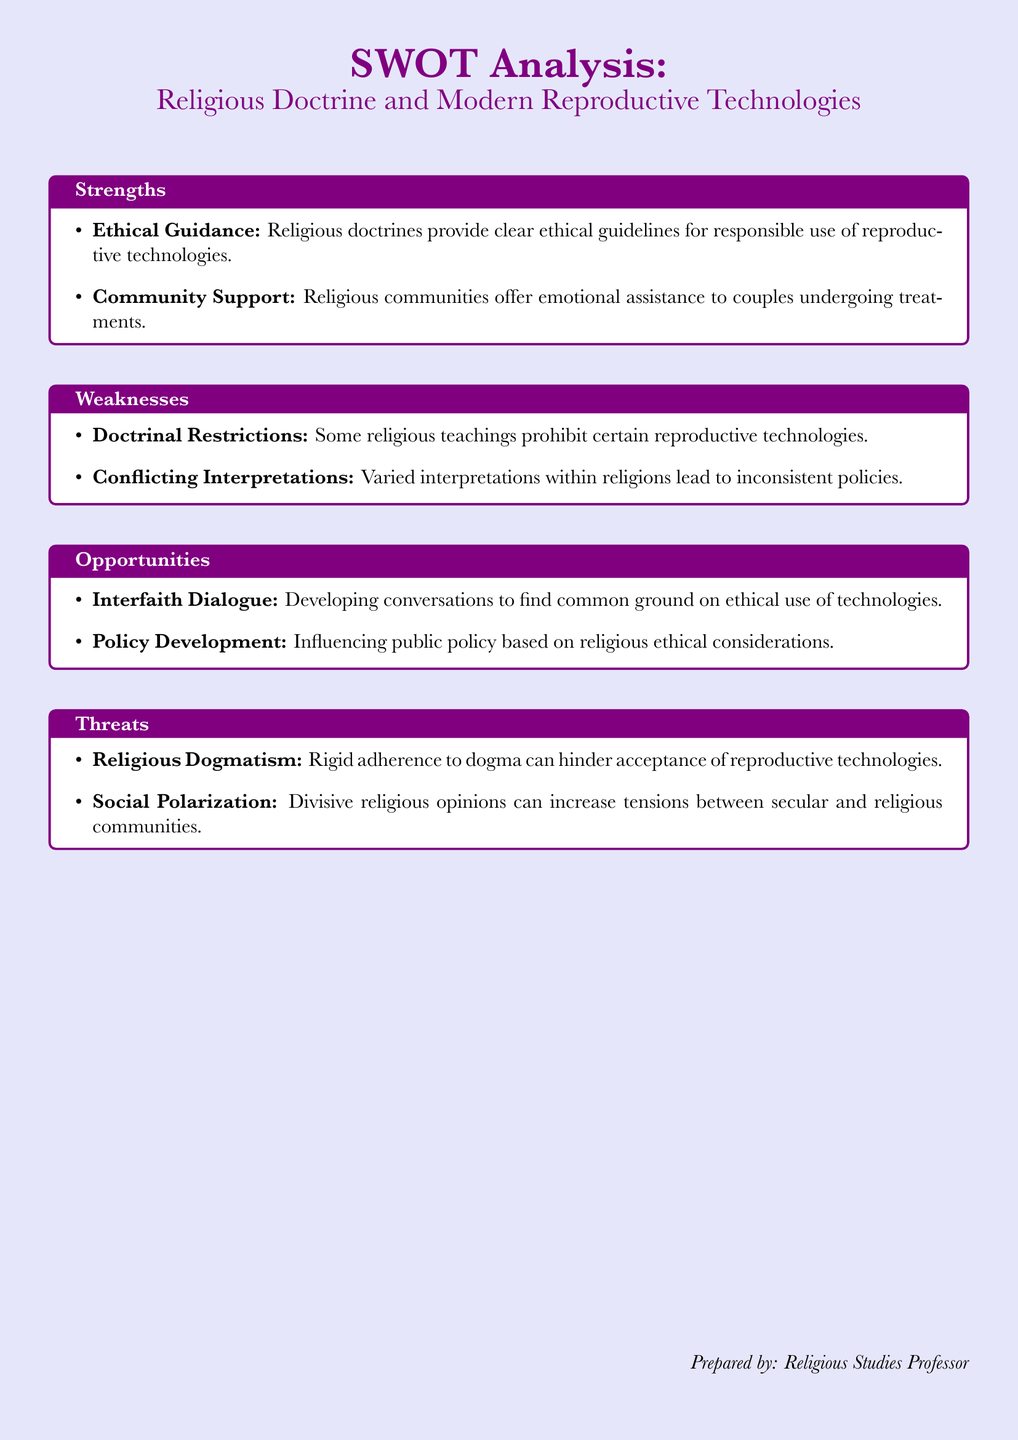What are the strengths listed in the analysis? The strengths are outlined in the first section of the SWOT analysis, specifically focusing on ethical guidance and community support.
Answer: Ethical Guidance, Community Support What is one weakness identified in the document? The weaknesses section highlights specific challenges faced within religious responses to reproductive technologies.
Answer: Doctrinal Restrictions What opportunities does the analysis suggest can be explored? The opportunities detail potential areas for advancement regarding the intersection of religion and reproductive technologies.
Answer: Interfaith Dialogue, Policy Development What threat involves the rigidity of religious beliefs? The threats section discusses issues that could hinder acceptance of reproductive technologies due to strict adherence to doctrine.
Answer: Religious Dogmatism How many strengths are listed in the document? The strengths section contains two key points related to the positive influence of religious doctrine on reproductive healthcare.
Answer: 2 What does the analysis suggest about social aspects of religious opinions? The threats highlight social implications that could arise from clashing views between religious and secular communities.
Answer: Social Polarization Which section outlines the ethical guidance provided by religious doctrines? This information is contained within the strengths section, focusing on how religious frameworks support ethical decision-making.
Answer: Strengths What is a specific example of conflicting interpretations within religions? The weaknesses section refers to this issue, indicating that varied interpretations can lead to inconsistent policies.
Answer: Conflicting Interpretations 